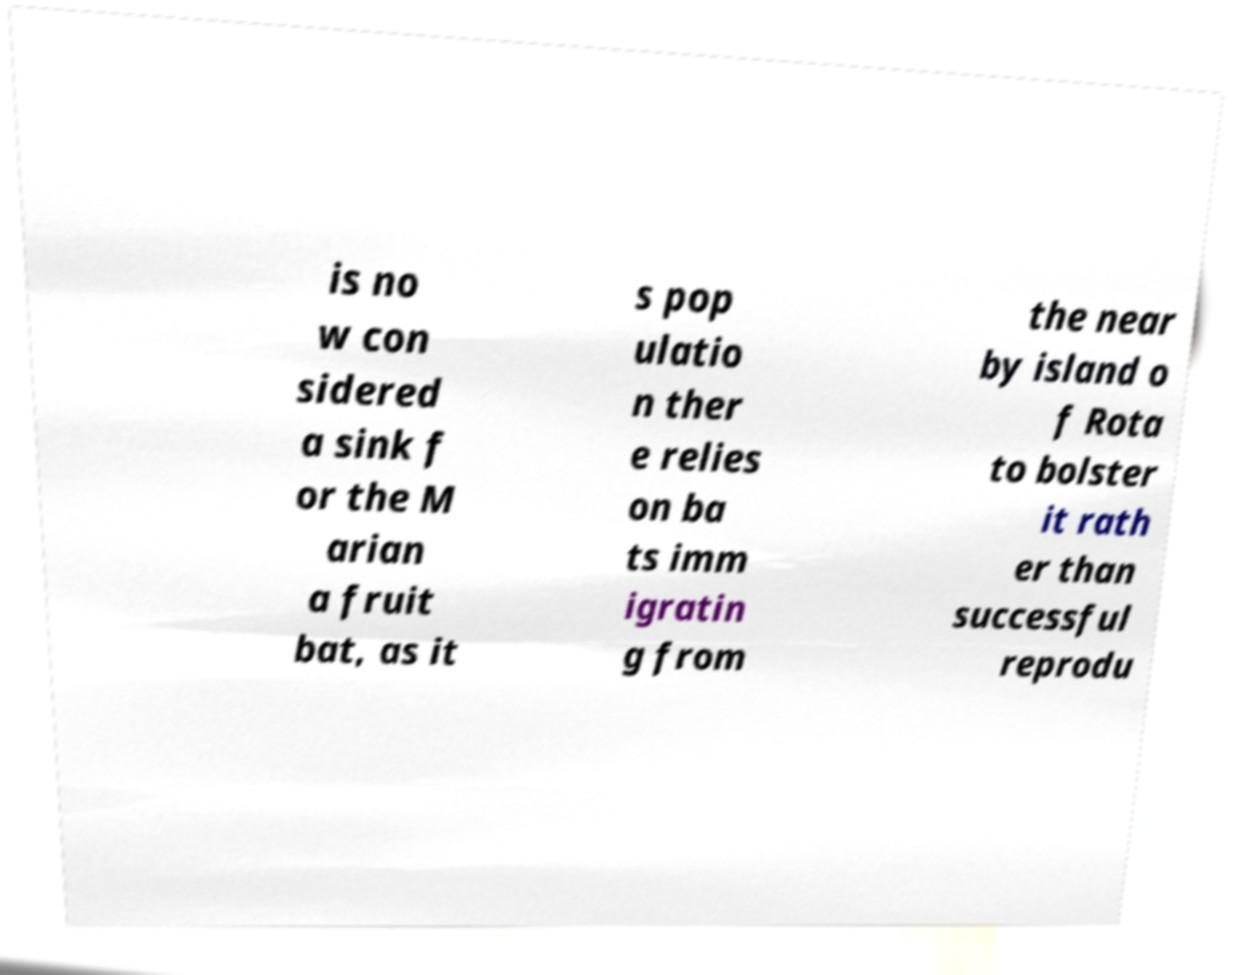I need the written content from this picture converted into text. Can you do that? is no w con sidered a sink f or the M arian a fruit bat, as it s pop ulatio n ther e relies on ba ts imm igratin g from the near by island o f Rota to bolster it rath er than successful reprodu 